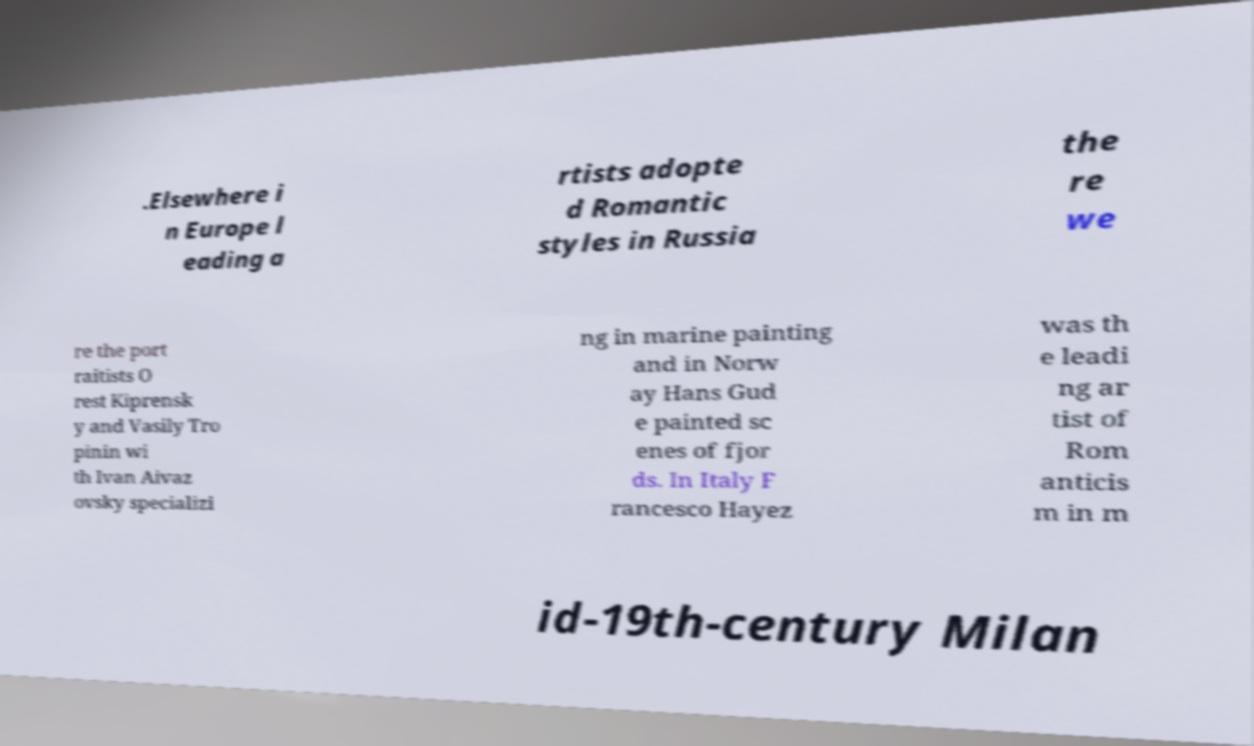Please identify and transcribe the text found in this image. .Elsewhere i n Europe l eading a rtists adopte d Romantic styles in Russia the re we re the port raitists O rest Kiprensk y and Vasily Tro pinin wi th Ivan Aivaz ovsky specializi ng in marine painting and in Norw ay Hans Gud e painted sc enes of fjor ds. In Italy F rancesco Hayez was th e leadi ng ar tist of Rom anticis m in m id-19th-century Milan 